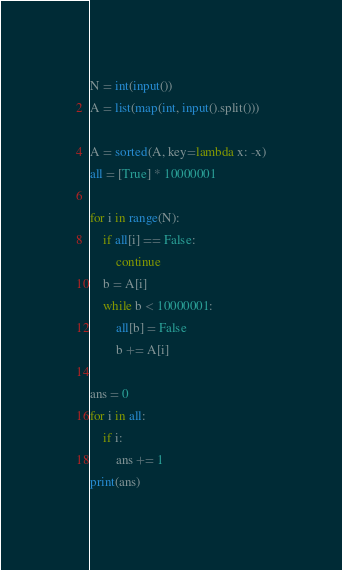<code> <loc_0><loc_0><loc_500><loc_500><_Python_>N = int(input())
A = list(map(int, input().split()))

A = sorted(A, key=lambda x: -x)
all = [True] * 10000001

for i in range(N):
    if all[i] == False:
        continue
    b = A[i]
    while b < 10000001:
        all[b] = False
        b += A[i]

ans = 0
for i in all:
    if i:
        ans += 1
print(ans)</code> 